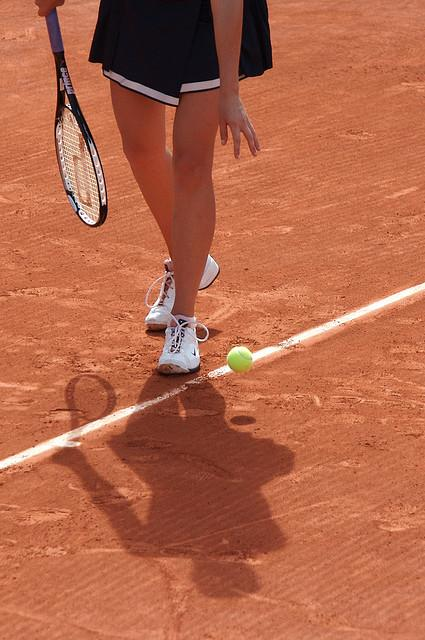What color are the logos on the shoes which this tennis playing woman is wearing? Please explain your reasoning. black. The logos on the side of the shoes is black. 